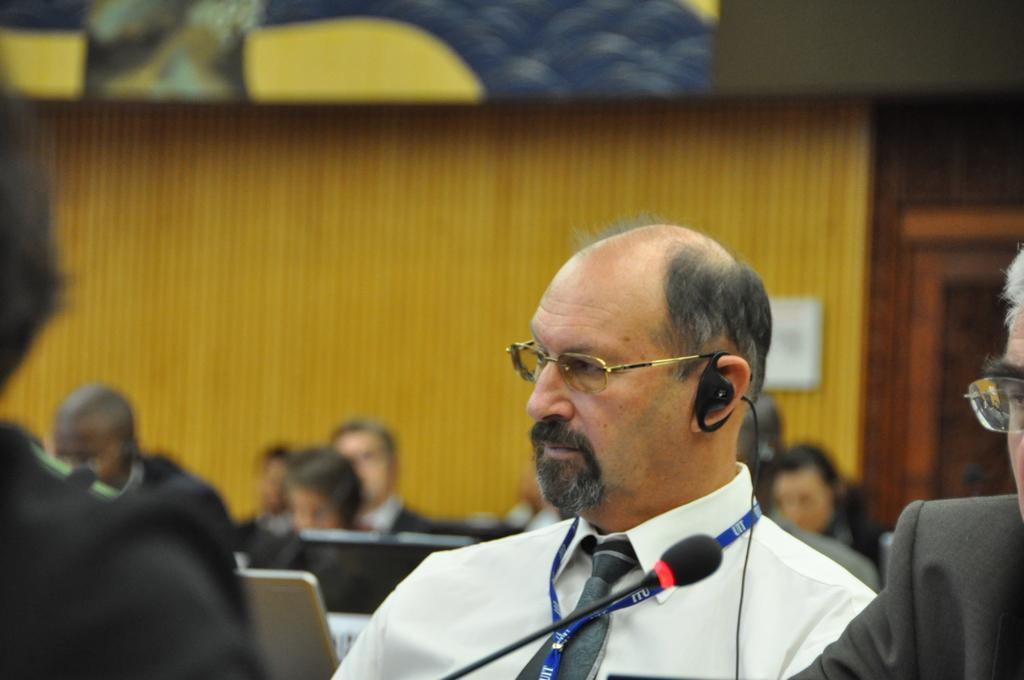What are the people in the image doing? The people in the image are sitting. Can you describe any specific features of the people in the front? Two persons in the front are wearing spectacles. What object is located at the bottom of the image? There is a microphone at the bottom of the image. What electronic devices can be seen in the image? There are laptops visible in the image. What can be seen in the background of the image? There is a wall in the background of the image. Can you tell me how many donkeys are present in the image? There are no donkeys present in the image. What type of cabbage is being harvested in the background of the image? There is no cabbage or harvesting activity depicted in the image; it features people sitting with laptops and a microphone. 